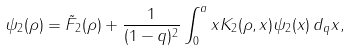<formula> <loc_0><loc_0><loc_500><loc_500>\psi _ { 2 } ( \rho ) = \tilde { F } _ { 2 } ( \rho ) + \frac { 1 } { ( 1 - q ) ^ { 2 } } \int _ { 0 } ^ { a } x K _ { 2 } ( \rho , x ) \psi _ { 2 } ( x ) \, d _ { q } x ,</formula> 